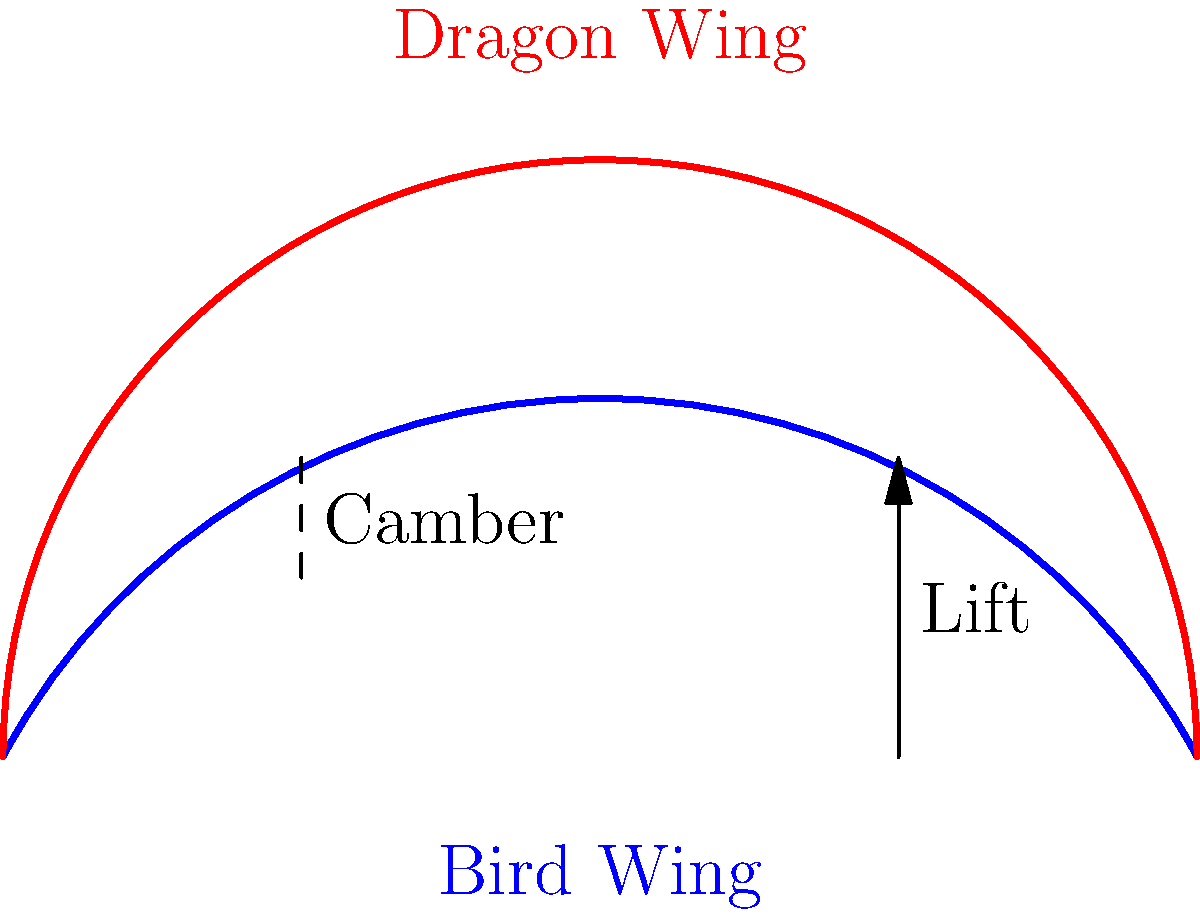Based on the anatomical illustrations of bird and dragon wings, which characteristic would likely contribute to more efficient gliding in dragons compared to large birds? To answer this question, let's analyze the key differences between the bird and dragon wing structures:

1. Wing shape: 
   - Bird wing: Curved, with a moderate arch
   - Dragon wing: More pronounced arch, creating a deeper curve

2. Camber:
   - In aerodynamics, camber refers to the asymmetry between the top and bottom surfaces of an airfoil.
   - The dragon wing shows a higher camber compared to the bird wing.

3. Lift generation:
   - Higher camber generally produces more lift at a given angle of attack.
   - The increased curvature of the dragon wing would create a greater pressure difference between the upper and lower surfaces.

4. Gliding efficiency:
   - Gliding relies on generating lift while minimizing drag.
   - The higher camber of the dragon wing would allow for more efficient lift generation at lower speeds.
   - This increased lift-to-drag ratio would contribute to more efficient gliding.

5. Mythological considerations:
   - In folklore, dragons are often depicted as efficient gliders, capable of soaring for long periods.
   - This anatomical difference supports the mythological accounts of dragon flight capabilities.

Therefore, the higher camber of the dragon wing would likely contribute to more efficient gliding compared to large birds.
Answer: Higher wing camber 